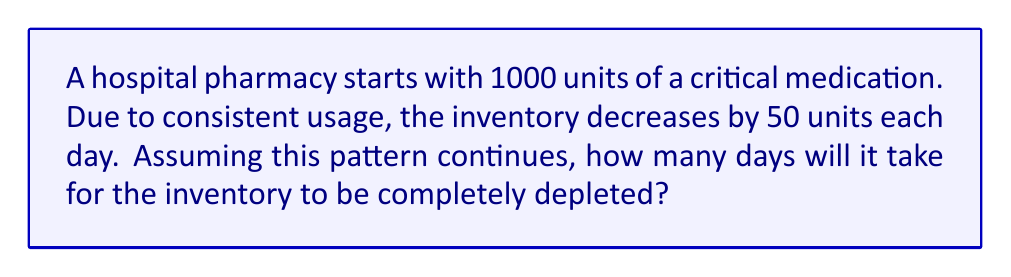Provide a solution to this math problem. Let's approach this step-by-step using an arithmetic sequence:

1) The initial term (a₁) is 1000 units.
2) The common difference (d) is -50 units per day.
3) We need to find the number of terms (n) when the last term (aₙ) becomes 0.

Using the arithmetic sequence formula:
$$ a_n = a_1 + (n-1)d $$

Where:
$a_n = 0$ (final inventory)
$a_1 = 1000$ (initial inventory)
$d = -50$ (daily decrease)
$n$ = number of days (what we're solving for)

Substituting these values:
$$ 0 = 1000 + (n-1)(-50) $$

Simplifying:
$$ 0 = 1000 - 50n + 50 $$
$$ 0 = 1050 - 50n $$

Solving for n:
$$ 50n = 1050 $$
$$ n = \frac{1050}{50} = 21 $$

Therefore, it will take 21 days for the inventory to be completely depleted.
Answer: 21 days 